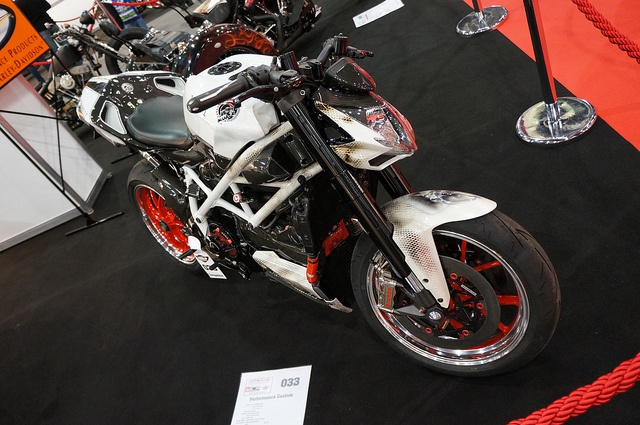Describe the objects in this image and their specific colors. I can see motorcycle in red, black, lightgray, gray, and darkgray tones, motorcycle in red, black, maroon, gray, and darkgray tones, and motorcycle in red, black, gray, darkgray, and lightgray tones in this image. 